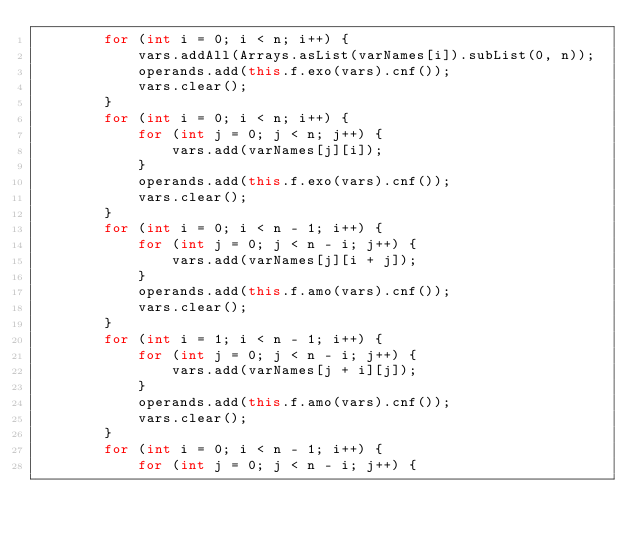<code> <loc_0><loc_0><loc_500><loc_500><_Java_>        for (int i = 0; i < n; i++) {
            vars.addAll(Arrays.asList(varNames[i]).subList(0, n));
            operands.add(this.f.exo(vars).cnf());
            vars.clear();
        }
        for (int i = 0; i < n; i++) {
            for (int j = 0; j < n; j++) {
                vars.add(varNames[j][i]);
            }
            operands.add(this.f.exo(vars).cnf());
            vars.clear();
        }
        for (int i = 0; i < n - 1; i++) {
            for (int j = 0; j < n - i; j++) {
                vars.add(varNames[j][i + j]);
            }
            operands.add(this.f.amo(vars).cnf());
            vars.clear();
        }
        for (int i = 1; i < n - 1; i++) {
            for (int j = 0; j < n - i; j++) {
                vars.add(varNames[j + i][j]);
            }
            operands.add(this.f.amo(vars).cnf());
            vars.clear();
        }
        for (int i = 0; i < n - 1; i++) {
            for (int j = 0; j < n - i; j++) {</code> 